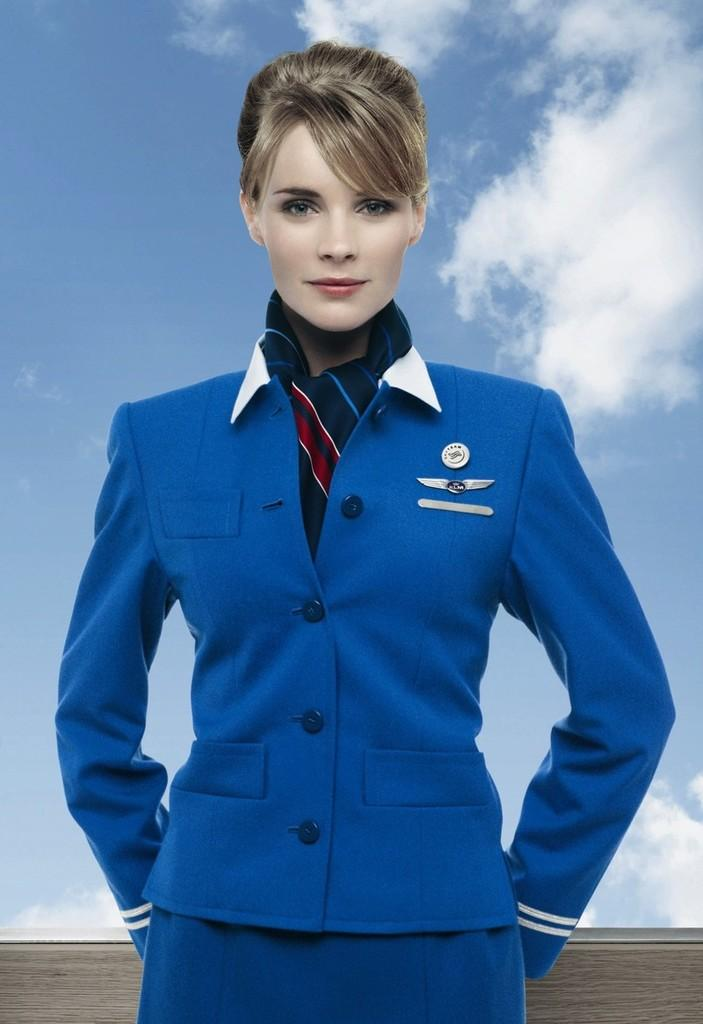Who is the main subject in the image? There is a woman in the image. Where is the woman located in the image? The woman is in the middle of the image. What is the woman wearing? The woman is wearing clothes. What is the woman's facial expression? The woman is smiling. What can be seen in the background of the image? The sky is visible in the image. What is the condition of the sky in the image? The sky appears to be cloudy. What type of basketball is the woman holding in the image? There is no basketball present in the image. Is the woman writing in a notebook in the image? There is no notebook present in the image. 